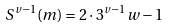Convert formula to latex. <formula><loc_0><loc_0><loc_500><loc_500>S ^ { v - 1 } ( m ) = 2 \cdot 3 ^ { v - 1 } w - 1</formula> 